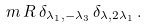<formula> <loc_0><loc_0><loc_500><loc_500>m \, R \, \delta _ { \lambda _ { 1 } , - \lambda _ { 3 } } \, \delta _ { \lambda , 2 \lambda _ { 1 } } \, .</formula> 